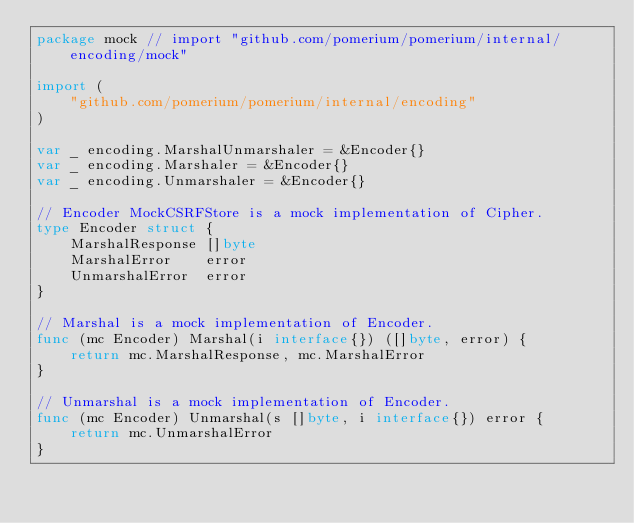<code> <loc_0><loc_0><loc_500><loc_500><_Go_>package mock // import "github.com/pomerium/pomerium/internal/encoding/mock"

import (
	"github.com/pomerium/pomerium/internal/encoding"
)

var _ encoding.MarshalUnmarshaler = &Encoder{}
var _ encoding.Marshaler = &Encoder{}
var _ encoding.Unmarshaler = &Encoder{}

// Encoder MockCSRFStore is a mock implementation of Cipher.
type Encoder struct {
	MarshalResponse []byte
	MarshalError    error
	UnmarshalError  error
}

// Marshal is a mock implementation of Encoder.
func (mc Encoder) Marshal(i interface{}) ([]byte, error) {
	return mc.MarshalResponse, mc.MarshalError
}

// Unmarshal is a mock implementation of Encoder.
func (mc Encoder) Unmarshal(s []byte, i interface{}) error {
	return mc.UnmarshalError
}
</code> 